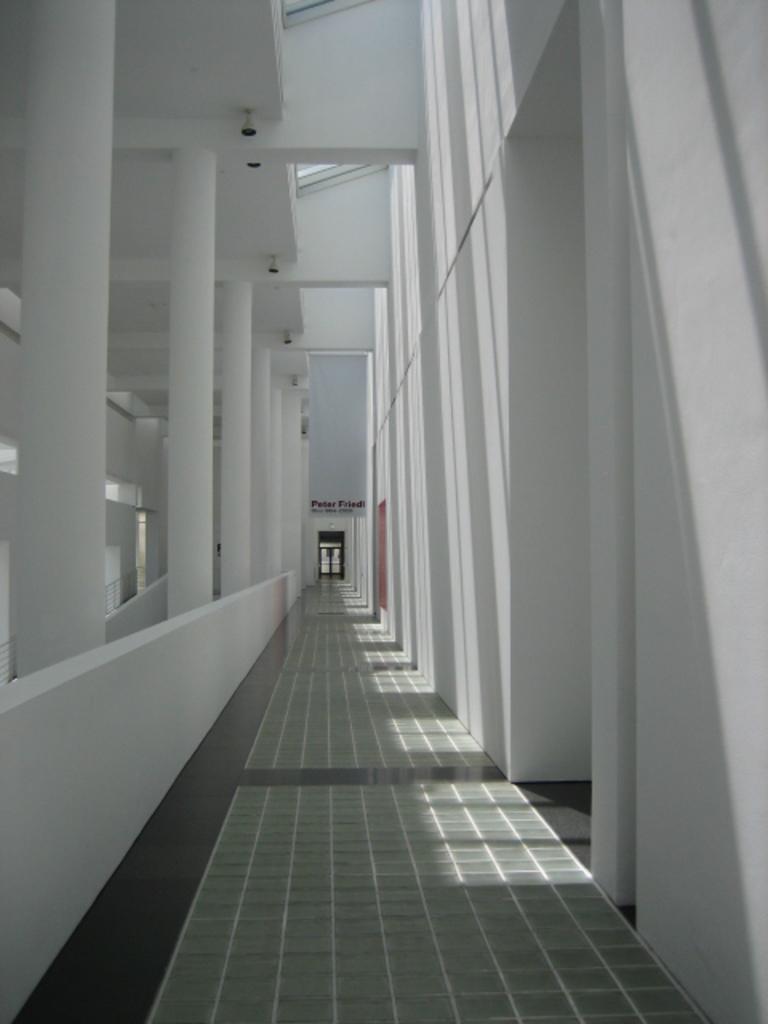Could you give a brief overview of what you see in this image? This image is clicked inside a building. In the middle there are pillars, wall, floor, lights, roof. In the background there is a room, text. 